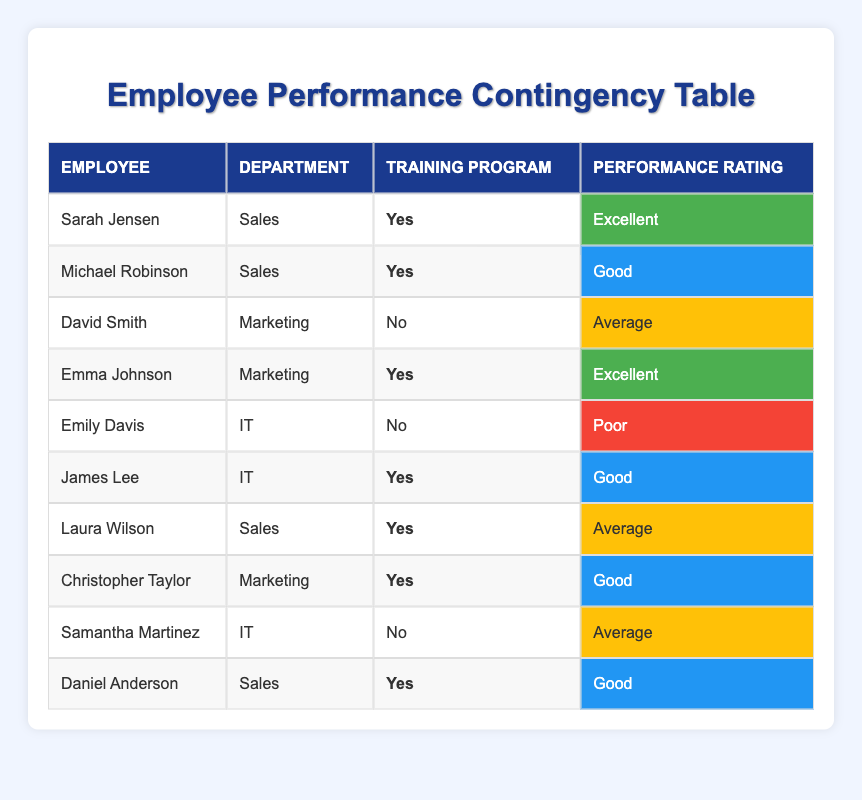What is the performance rating of Sarah Jensen? Sarah Jensen is listed in the "Employee" column and her corresponding "Performance Rating," which is "Excellent," can be found in the relevant row.
Answer: Excellent How many employees participated in the training program? To find the number of employees who participated in the training program, we can count the "Yes" responses under the "Training Program" column. There are five employees listed with "Yes."
Answer: 5 What is the performance rating of employees in the IT department who did not participate in the training program? In the IT department, there are two employees listed: Emily Davis (who did not participate in training) with a rating of "Poor" and Samantha Martinez (who also did not participate) with a rating of "Average." The performance ratings for the IT department are "Poor" and "Average."
Answer: Poor and Average How many employees rated as "Excellent" participated in the training program? We can review the table for employees with a performance rating of "Excellent." There are two employees, Sarah Jensen and Emma Johnson, who both participated in the training program, confirming there are two "Excellent" ratings related to training.
Answer: 2 Is there any employee in the Marketing department with a performance rating of "Poor"? Reviewing the Marketing department entries, David Smith has a rating of "Average," and Emma Johnson has "Excellent." Since none have a rating of "Poor," the answer is "No."
Answer: No What is the average performance rating for employees in the Sales department who participated in the training program? The performance ratings for the Sales department employees who participated in training are "Excellent," "Good," and "Average" (Sarah Jensen, Michael Robinson, and Laura Wilson). Averaging these can be considered by assigning values: Excellent (3), Good (2), and Average (1). The average is calculated as (3 + 2 + 1) / 3 = 2 => which is "Good".
Answer: Good How many employees in the IT department received a performance rating of "Good"? Analyzing the IT department, we have James Lee with a rating of "Good" and Emily Davis (Poor) and Samantha Martinez (Average). Therefore, only one employee in IT received "Good."
Answer: 1 What percentage of the employees in the Sales department had an "Average" rating? The Sales department has four total employees (Sarah Jensen, Michael Robinson, Laura Wilson, and Daniel Anderson) and one of them, Laura Wilson, received an "Average" rating. Thus, the percentage is (1/4) * 100 = 25%.
Answer: 25% How many employees from the Marketing department participated in the training program? In the Marketing department, Emma Johnson and Christopher Taylor both participated in training. Thus, there are two employees from Marketing who took part in the training program.
Answer: 2 